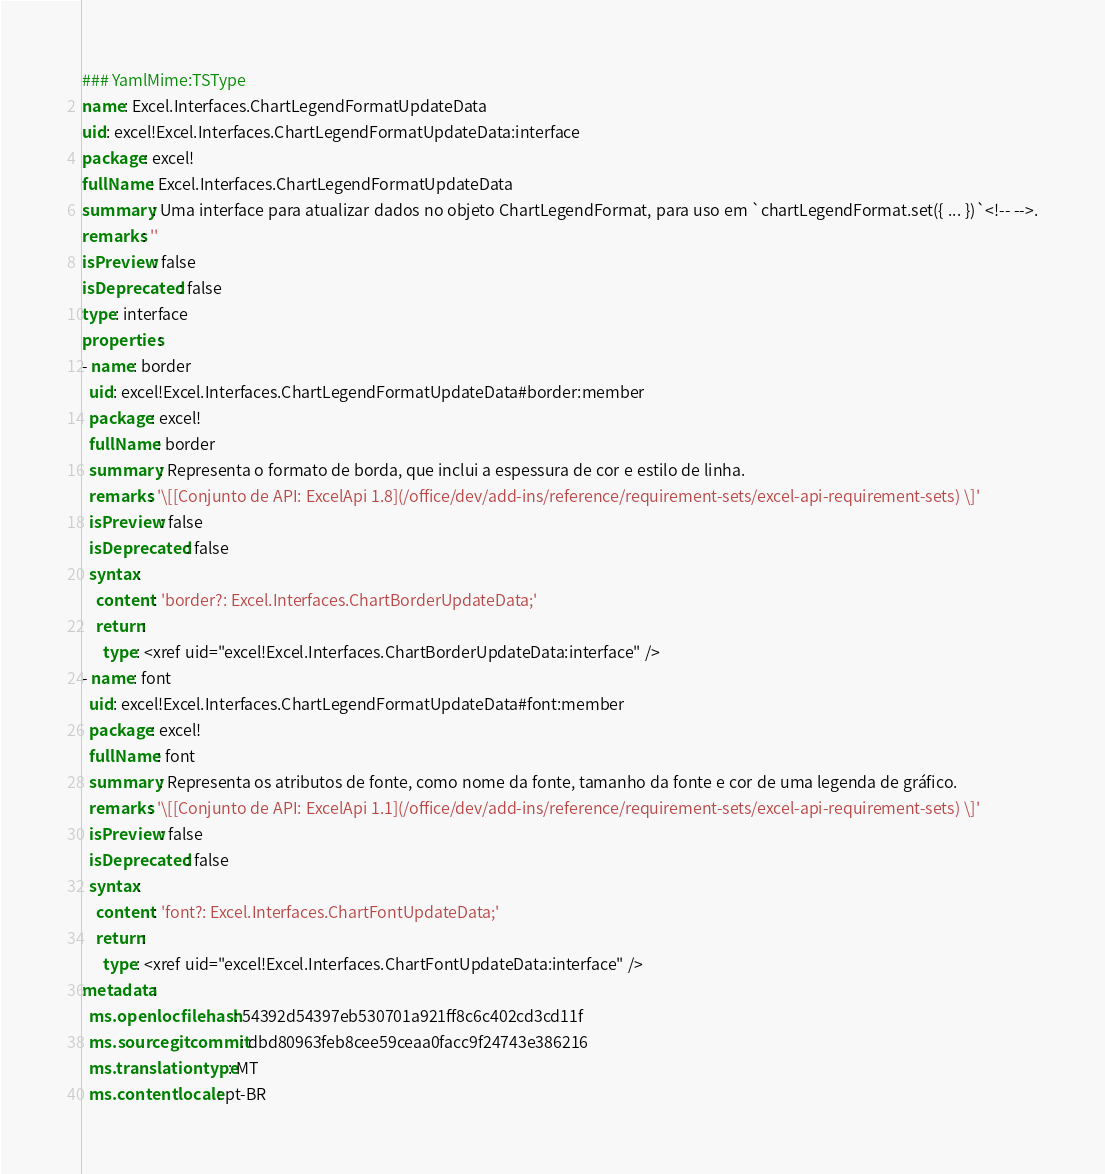<code> <loc_0><loc_0><loc_500><loc_500><_YAML_>### YamlMime:TSType
name: Excel.Interfaces.ChartLegendFormatUpdateData
uid: excel!Excel.Interfaces.ChartLegendFormatUpdateData:interface
package: excel!
fullName: Excel.Interfaces.ChartLegendFormatUpdateData
summary: Uma interface para atualizar dados no objeto ChartLegendFormat, para uso em `chartLegendFormat.set({ ... })`<!-- -->.
remarks: ''
isPreview: false
isDeprecated: false
type: interface
properties:
- name: border
  uid: excel!Excel.Interfaces.ChartLegendFormatUpdateData#border:member
  package: excel!
  fullName: border
  summary: Representa o formato de borda, que inclui a espessura de cor e estilo de linha.
  remarks: '\[[Conjunto de API: ExcelApi 1.8](/office/dev/add-ins/reference/requirement-sets/excel-api-requirement-sets) \]'
  isPreview: false
  isDeprecated: false
  syntax:
    content: 'border?: Excel.Interfaces.ChartBorderUpdateData;'
    return:
      type: <xref uid="excel!Excel.Interfaces.ChartBorderUpdateData:interface" />
- name: font
  uid: excel!Excel.Interfaces.ChartLegendFormatUpdateData#font:member
  package: excel!
  fullName: font
  summary: Representa os atributos de fonte, como nome da fonte, tamanho da fonte e cor de uma legenda de gráfico.
  remarks: '\[[Conjunto de API: ExcelApi 1.1](/office/dev/add-ins/reference/requirement-sets/excel-api-requirement-sets) \]'
  isPreview: false
  isDeprecated: false
  syntax:
    content: 'font?: Excel.Interfaces.ChartFontUpdateData;'
    return:
      type: <xref uid="excel!Excel.Interfaces.ChartFontUpdateData:interface" />
metadata:
  ms.openlocfilehash: 54392d54397eb530701a921ff8c6c402cd3cd11f
  ms.sourcegitcommit: dbd80963feb8cee59ceaa0facc9f24743e386216
  ms.translationtype: MT
  ms.contentlocale: pt-BR</code> 